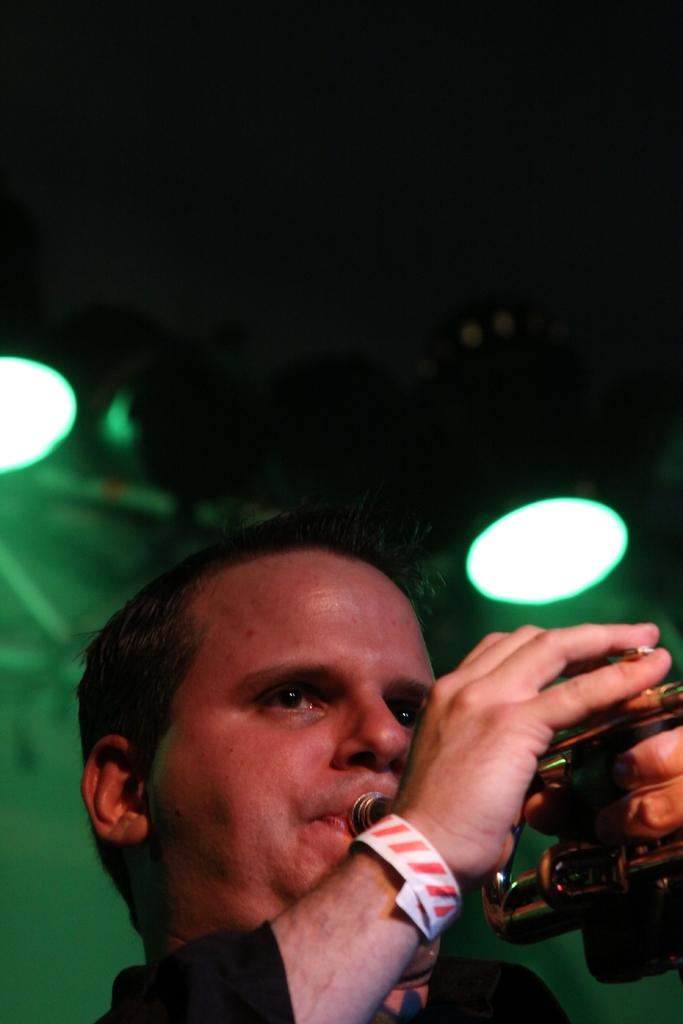What is the main subject of the image? There is a person in the image. What is the person wearing? The person is wearing a black dress. What is the person doing in the image? The person is playing a trumpet. What can be seen in the background of the image? There are lights visible in the background of the image. How many trains can be seen in the image? There are no trains present in the image. What type of hobbies does the person have, based on the image? The image only shows the person playing a trumpet, so it cannot be determined what other hobbies they might have. 